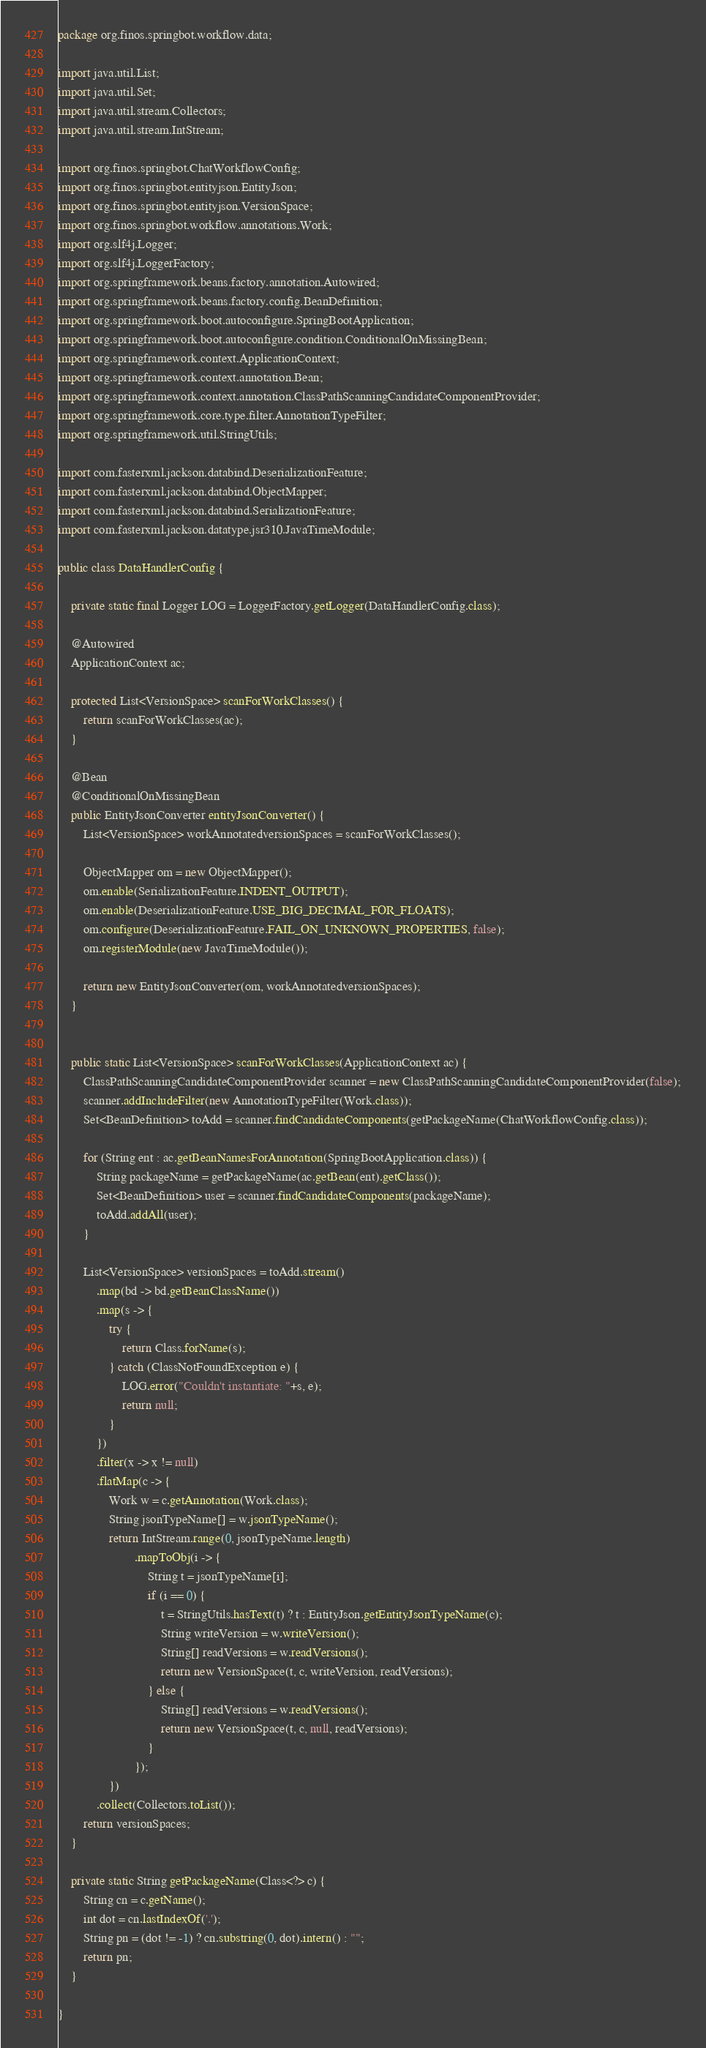<code> <loc_0><loc_0><loc_500><loc_500><_Java_>package org.finos.springbot.workflow.data;

import java.util.List;
import java.util.Set;
import java.util.stream.Collectors;
import java.util.stream.IntStream;

import org.finos.springbot.ChatWorkflowConfig;
import org.finos.springbot.entityjson.EntityJson;
import org.finos.springbot.entityjson.VersionSpace;
import org.finos.springbot.workflow.annotations.Work;
import org.slf4j.Logger;
import org.slf4j.LoggerFactory;
import org.springframework.beans.factory.annotation.Autowired;
import org.springframework.beans.factory.config.BeanDefinition;
import org.springframework.boot.autoconfigure.SpringBootApplication;
import org.springframework.boot.autoconfigure.condition.ConditionalOnMissingBean;
import org.springframework.context.ApplicationContext;
import org.springframework.context.annotation.Bean;
import org.springframework.context.annotation.ClassPathScanningCandidateComponentProvider;
import org.springframework.core.type.filter.AnnotationTypeFilter;
import org.springframework.util.StringUtils;

import com.fasterxml.jackson.databind.DeserializationFeature;
import com.fasterxml.jackson.databind.ObjectMapper;
import com.fasterxml.jackson.databind.SerializationFeature;
import com.fasterxml.jackson.datatype.jsr310.JavaTimeModule;

public class DataHandlerConfig {

	private static final Logger LOG = LoggerFactory.getLogger(DataHandlerConfig.class);

	@Autowired
	ApplicationContext ac;
	
	protected List<VersionSpace> scanForWorkClasses() {
		return scanForWorkClasses(ac);
	}
	
	@Bean
	@ConditionalOnMissingBean
	public EntityJsonConverter entityJsonConverter() {
		List<VersionSpace> workAnnotatedversionSpaces = scanForWorkClasses();
		
		ObjectMapper om = new ObjectMapper();
		om.enable(SerializationFeature.INDENT_OUTPUT);
		om.enable(DeserializationFeature.USE_BIG_DECIMAL_FOR_FLOATS);
		om.configure(DeserializationFeature.FAIL_ON_UNKNOWN_PROPERTIES, false);
		om.registerModule(new JavaTimeModule());
				
		return new EntityJsonConverter(om, workAnnotatedversionSpaces);
	}
	
	
	public static List<VersionSpace> scanForWorkClasses(ApplicationContext ac) {
		ClassPathScanningCandidateComponentProvider scanner = new ClassPathScanningCandidateComponentProvider(false);
		scanner.addIncludeFilter(new AnnotationTypeFilter(Work.class));
		Set<BeanDefinition> toAdd = scanner.findCandidateComponents(getPackageName(ChatWorkflowConfig.class));
		
		for (String ent : ac.getBeanNamesForAnnotation(SpringBootApplication.class)) {
			String packageName = getPackageName(ac.getBean(ent).getClass());
			Set<BeanDefinition> user = scanner.findCandidateComponents(packageName);
			toAdd.addAll(user);
		}
		
		List<VersionSpace> versionSpaces = toAdd.stream()
			.map(bd -> bd.getBeanClassName()) 
			.map(s -> {
				try {
					return Class.forName(s);
				} catch (ClassNotFoundException e) {
					LOG.error("Couldn't instantiate: "+s, e);
					return null;
				}
			})
			.filter(x -> x != null) 
			.flatMap(c -> {
				Work w = c.getAnnotation(Work.class);
				String jsonTypeName[] = w.jsonTypeName();
				return IntStream.range(0, jsonTypeName.length)
						.mapToObj(i -> {
							String t = jsonTypeName[i];
							if (i == 0) {
								t = StringUtils.hasText(t) ? t : EntityJson.getEntityJsonTypeName(c);
								String writeVersion = w.writeVersion();
								String[] readVersions = w.readVersions();
								return new VersionSpace(t, c, writeVersion, readVersions);
							} else {
								String[] readVersions = w.readVersions();
								return new VersionSpace(t, c, null, readVersions);
							}
						});
				})
			.collect(Collectors.toList());
		return versionSpaces;
	}

	private static String getPackageName(Class<?> c) {
		String cn = c.getName();
        int dot = cn.lastIndexOf('.');
        String pn = (dot != -1) ? cn.substring(0, dot).intern() : "";
        return pn;
	}

}
</code> 